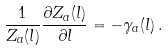Convert formula to latex. <formula><loc_0><loc_0><loc_500><loc_500>\frac { 1 } { Z _ { a } ( l ) } \frac { \partial Z _ { a } ( l ) } { \partial l } = - \gamma _ { a } ( l ) \, .</formula> 